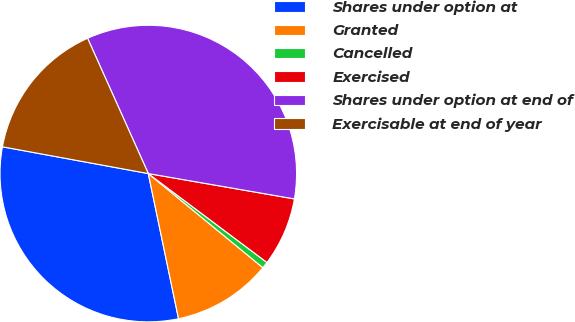<chart> <loc_0><loc_0><loc_500><loc_500><pie_chart><fcel>Shares under option at<fcel>Granted<fcel>Cancelled<fcel>Exercised<fcel>Shares under option at end of<fcel>Exercisable at end of year<nl><fcel>31.16%<fcel>10.79%<fcel>0.71%<fcel>7.5%<fcel>34.45%<fcel>15.4%<nl></chart> 